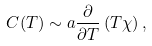Convert formula to latex. <formula><loc_0><loc_0><loc_500><loc_500>C ( T ) \sim a \frac { \partial } { \partial T } \left ( T \chi \right ) ,</formula> 